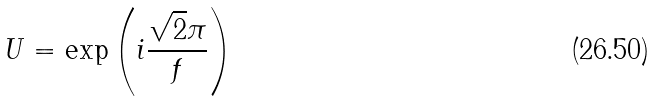<formula> <loc_0><loc_0><loc_500><loc_500>U = \exp \left ( i \frac { \sqrt { 2 } \pi } { f } \right )</formula> 